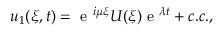<formula> <loc_0><loc_0><loc_500><loc_500>u _ { 1 } ( \xi , t ) = e ^ { i \mu \xi } U ( \xi ) e ^ { \lambda t } + c . c . ,</formula> 